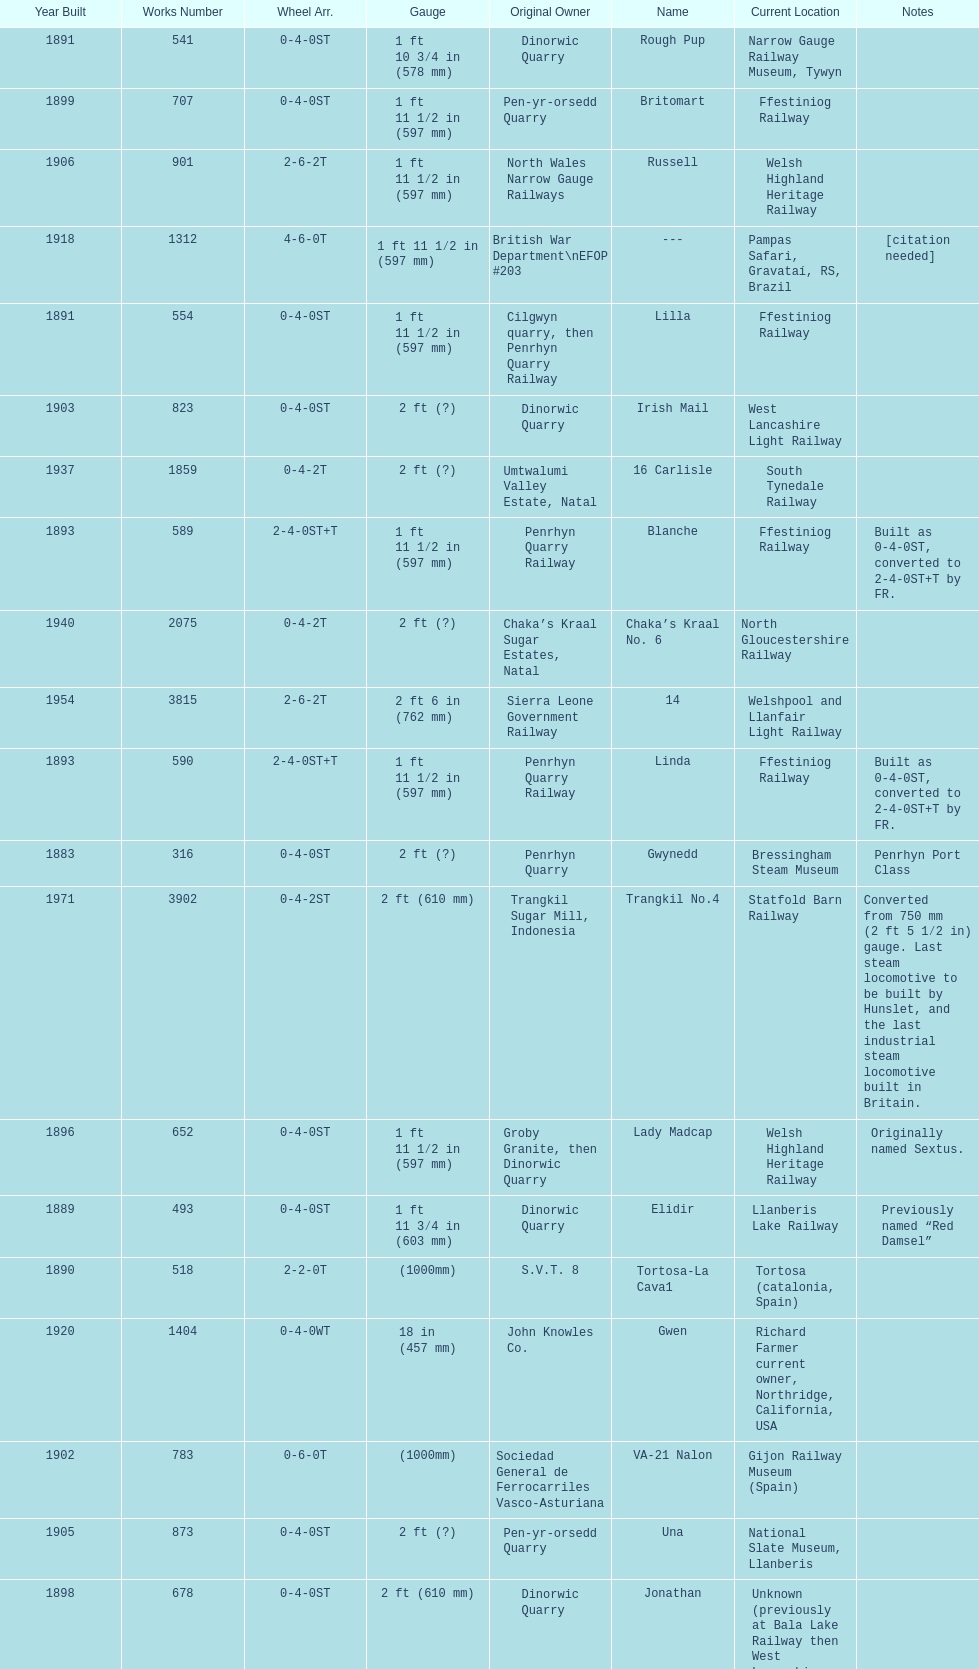How many steam locomotives are currently located at the bala lake railway? 364. 